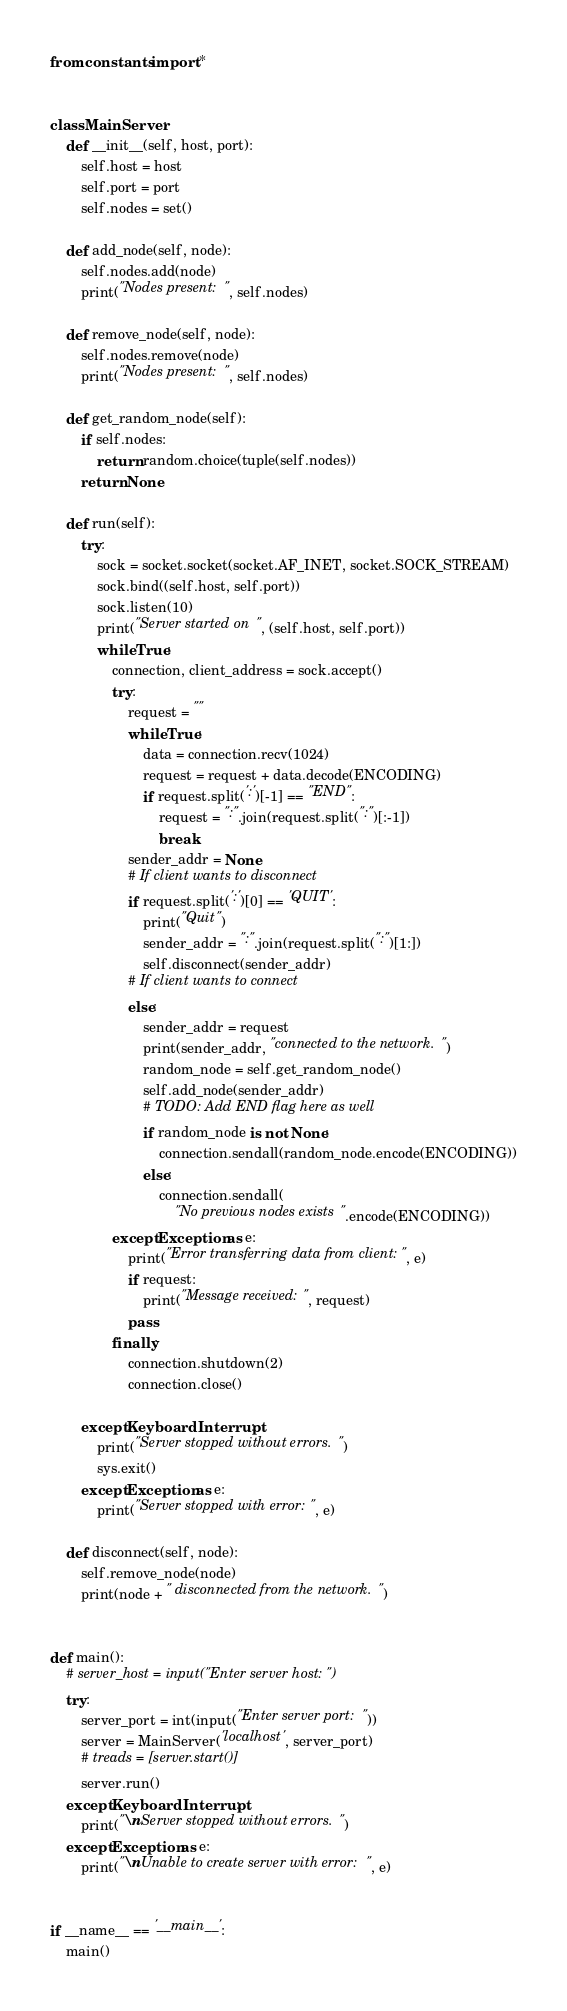<code> <loc_0><loc_0><loc_500><loc_500><_Python_>from constants import *


class MainServer:
    def __init__(self, host, port):
        self.host = host
        self.port = port
        self.nodes = set()

    def add_node(self, node):
        self.nodes.add(node)
        print("Nodes present: ", self.nodes)

    def remove_node(self, node):
        self.nodes.remove(node)
        print("Nodes present: ", self.nodes)

    def get_random_node(self):
        if self.nodes:
            return random.choice(tuple(self.nodes))
        return None

    def run(self):
        try:
            sock = socket.socket(socket.AF_INET, socket.SOCK_STREAM)
            sock.bind((self.host, self.port))
            sock.listen(10)
            print("Server started on ", (self.host, self.port))
            while True:
                connection, client_address = sock.accept()
                try:
                    request = ""
                    while True:
                        data = connection.recv(1024)
                        request = request + data.decode(ENCODING)
                        if request.split(':')[-1] == "END":
                            request = ":".join(request.split(":")[:-1])
                            break
                    sender_addr = None
                    # If client wants to disconnect
                    if request.split(':')[0] == 'QUIT':
                        print("Quit")
                        sender_addr = ":".join(request.split(":")[1:])
                        self.disconnect(sender_addr)
                    # If client wants to connect
                    else:
                        sender_addr = request
                        print(sender_addr, "connected to the network.")
                        random_node = self.get_random_node()
                        self.add_node(sender_addr)
                        # TODO: Add END flag here as well
                        if random_node is not None:
                            connection.sendall(random_node.encode(ENCODING))
                        else:
                            connection.sendall(
                                "No previous nodes exists".encode(ENCODING))
                except Exception as e:
                    print("Error transferring data from client:", e)
                    if request:
                        print("Message received:", request)
                    pass
                finally:
                    connection.shutdown(2)
                    connection.close()

        except KeyboardInterrupt:
            print("Server stopped without errors.")
            sys.exit()
        except Exception as e:
            print("Server stopped with error:", e)

    def disconnect(self, node):
        self.remove_node(node)
        print(node + " disconnected from the network.")


def main():
    # server_host = input("Enter server host: ")
    try:
        server_port = int(input("Enter server port: "))
        server = MainServer('localhost', server_port)
        # treads = [server.start()]
        server.run()
    except KeyboardInterrupt:
        print("\nServer stopped without errors.")
    except Exception as e:
        print("\nUnable to create server with error:", e)


if __name__ == '__main__':
    main()
</code> 